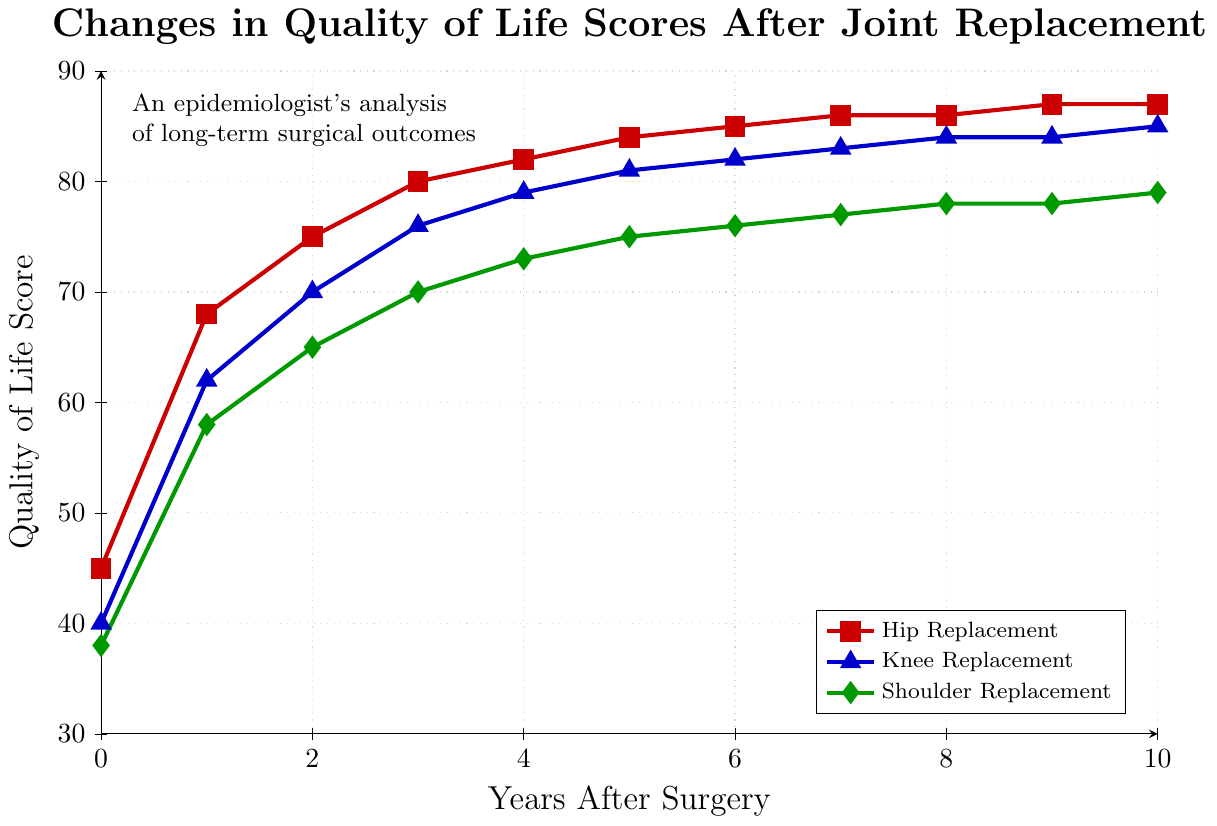Which surgery type shows the highest initial quality of life score? Look at the y-axis value for year 0 for each surgery. Hip Replacement starts at 45, Knee Replacement at 40, and Shoulder Replacement at 38. The highest initial score is Hip Replacement.
Answer: Hip Replacement What is the magnitude of the increase in quality of life scores for Hip Replacement from year 0 to year 1? Subtract the quality of life score at year 0 from the score at year 1 for Hip Replacement. Year 1 score is 68, and year 0 score is 45. 68 - 45 = 23.
Answer: 23 Which surgery type has the smallest quality of life improvement from year 0 to year 10? Calculate the difference between year 0 and year 10 scores for each surgery type: Hip Replacement (87 - 45 = 42), Knee Replacement (85 - 40 = 45), and Shoulder Replacement (79 - 38 = 41). The smallest improvement is for Shoulder Replacement.
Answer: Shoulder Replacement Between Knee Replacement and Shoulder Replacement, which has a closer final (year 10) quality of life score to that of Hip Replacement? Compare the year 10 scores: Hip Replacement (87), Knee Replacement (85), Shoulder Replacement (79). Knee Replacement's score (85) is closer to 87 than Shoulder Replacement's (79).
Answer: Knee Replacement What is the average quality of life score for Shoulder Replacement over the 10-year period? Add the quality of life scores for Shoulder Replacement at each year and divide by 11: (38 + 58 + 65 + 70 + 73 + 75 + 76 + 77 + 78 + 78 + 79) / 11 = 69
Answer: 69 In which year do all three surgeries converge to within a 10-point range from each other for the first time? Check each year for the ranges: By year 4, ranges for the surgeries are Hip Replacement (82), Knee Replacement (79), and Shoulder Replacement (73). The maximum difference is 9 points. This is the first instance within a 10-point range.
Answer: Year 4 Did the quality of life score for Knee Replacement ever decrease? Examine the quality of life scores for Knee Replacement over the years. The scores always increase or stay the same.
Answer: No By how many points do Hip Replacement scores improve from year 5 to year 7? Subtract the score at year 5 from the score at year 7 for Hip Replacement. Year 7 score is 86, and year 5 score is 84. 86 - 84 = 2
Answer: 2 How many years does it take for Hip Replacement scores to first reach 80? Identify the first year where the Hip Replacement score is 80 or more. This happens first at year 3.
Answer: 3 years What is the difference between the final (year 10) quality of life scores of Hip Replacement and Shoulder Replacement? Subtract the year 10 score of Shoulder Replacement from that of Hip Replacement. Year 10 score for Hip Replacement is 87, and for Shoulder Replacement, it is 79. 87 - 79 = 8
Answer: 8 